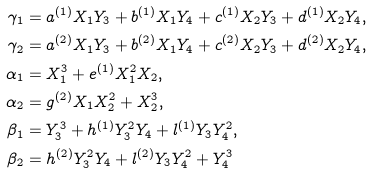Convert formula to latex. <formula><loc_0><loc_0><loc_500><loc_500>\gamma _ { 1 } & = a ^ { ( 1 ) } X _ { 1 } Y _ { 3 } + b ^ { ( 1 ) } X _ { 1 } Y _ { 4 } + c ^ { ( 1 ) } X _ { 2 } Y _ { 3 } + d ^ { ( 1 ) } X _ { 2 } Y _ { 4 } , \\ \gamma _ { 2 } & = a ^ { ( 2 ) } X _ { 1 } Y _ { 3 } + b ^ { ( 2 ) } X _ { 1 } Y _ { 4 } + c ^ { ( 2 ) } X _ { 2 } Y _ { 3 } + d ^ { ( 2 ) } X _ { 2 } Y _ { 4 } , \\ \alpha _ { 1 } & = X _ { 1 } ^ { 3 } + e ^ { ( 1 ) } X _ { 1 } ^ { 2 } X _ { 2 } , \\ \alpha _ { 2 } & = g ^ { ( 2 ) } X _ { 1 } X _ { 2 } ^ { 2 } + X _ { 2 } ^ { 3 } , \\ \beta _ { 1 } & = Y _ { 3 } ^ { 3 } + h ^ { ( 1 ) } Y _ { 3 } ^ { 2 } Y _ { 4 } + l ^ { ( 1 ) } Y _ { 3 } Y _ { 4 } ^ { 2 } , \\ \beta _ { 2 } & = h ^ { ( 2 ) } Y _ { 3 } ^ { 2 } Y _ { 4 } + l ^ { ( 2 ) } Y _ { 3 } Y _ { 4 } ^ { 2 } + Y _ { 4 } ^ { 3 }</formula> 